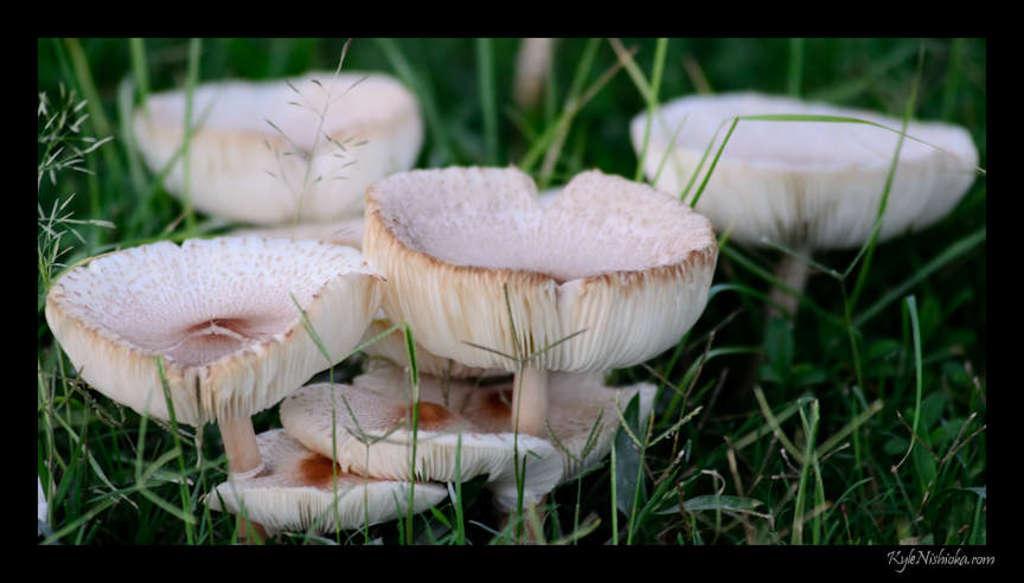How would you summarize this image in a sentence or two? The picture consists of mushrooms and grass. The picture has a black border. 